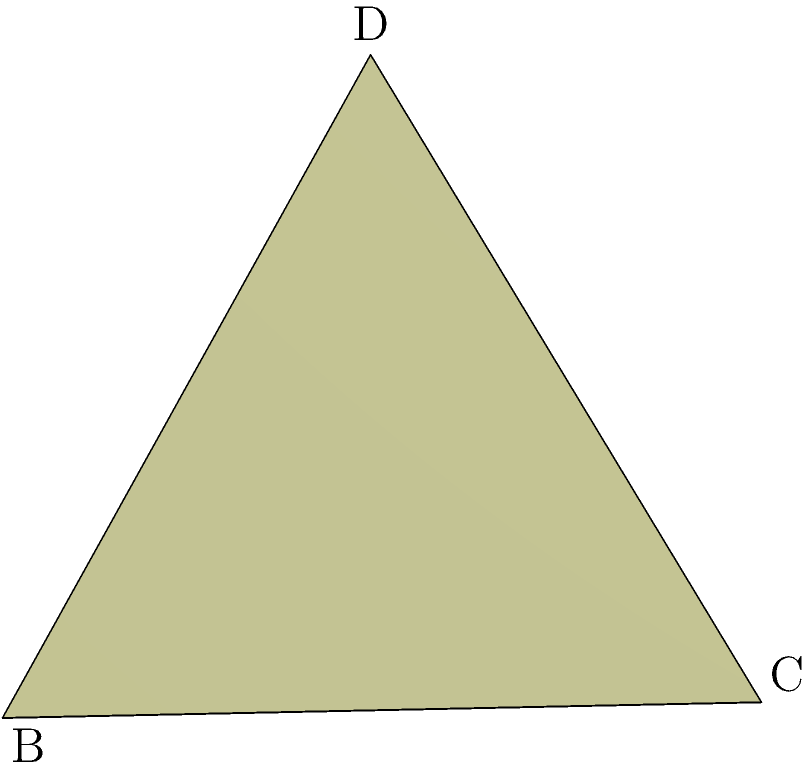In the context of tokenomics and smart contract design, consider a regular octahedron representing a multi-faceted DeFi protocol. If the edge length of this octahedron is $a$ units, which could represent the protocol's total value locked (TVL) in millions of ETH, what is the surface area of the entire octahedron? Express your answer in terms of $a^2$. To solve this problem, let's follow these steps:

1) A regular octahedron consists of 8 congruent equilateral triangles.

2) The surface area of the octahedron will be the sum of the areas of these 8 triangles.

3) For an equilateral triangle with side length $a$, the area is given by:

   $$A_{triangle} = \frac{\sqrt{3}}{4}a^2$$

4) Since there are 8 such triangles, the total surface area will be:

   $$SA_{octahedron} = 8 \cdot \frac{\sqrt{3}}{4}a^2$$

5) Simplifying:

   $$SA_{octahedron} = 2\sqrt{3}a^2$$

This formula gives us the surface area of the octahedron in terms of $a^2$, where $a$ represents the edge length or, in our DeFi analogy, the TVL in millions of ETH.
Answer: $2\sqrt{3}a^2$ 